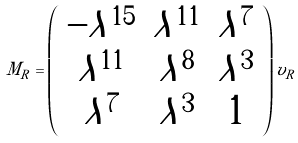Convert formula to latex. <formula><loc_0><loc_0><loc_500><loc_500>M _ { R } = \left ( \begin{array} { c c c } - \lambda ^ { 1 5 } & \lambda ^ { 1 1 } & \lambda ^ { 7 } \\ \lambda ^ { 1 1 } & \lambda ^ { 8 } & \lambda ^ { 3 } \\ \lambda ^ { 7 } & \lambda ^ { 3 } & 1 \end{array} \right ) v _ { R }</formula> 